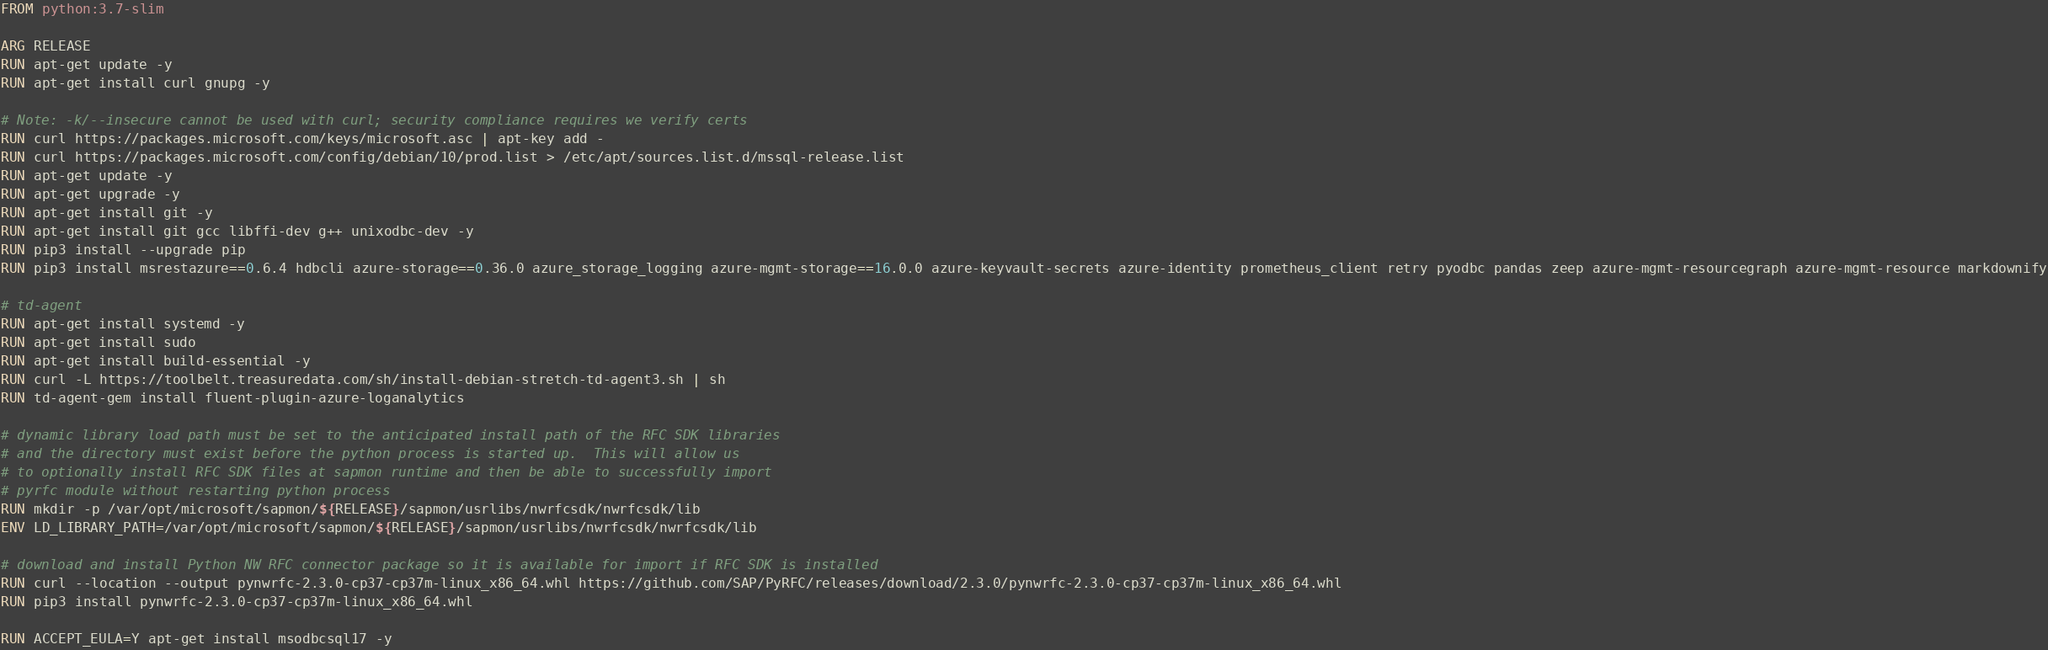<code> <loc_0><loc_0><loc_500><loc_500><_Dockerfile_>FROM python:3.7-slim

ARG RELEASE
RUN apt-get update -y
RUN apt-get install curl gnupg -y

# Note: -k/--insecure cannot be used with curl; security compliance requires we verify certs
RUN curl https://packages.microsoft.com/keys/microsoft.asc | apt-key add -
RUN curl https://packages.microsoft.com/config/debian/10/prod.list > /etc/apt/sources.list.d/mssql-release.list
RUN apt-get update -y
RUN apt-get upgrade -y
RUN apt-get install git -y
RUN apt-get install git gcc libffi-dev g++ unixodbc-dev -y
RUN pip3 install --upgrade pip
RUN pip3 install msrestazure==0.6.4 hdbcli azure-storage==0.36.0 azure_storage_logging azure-mgmt-storage==16.0.0 azure-keyvault-secrets azure-identity prometheus_client retry pyodbc pandas zeep azure-mgmt-resourcegraph azure-mgmt-resource markdownify

# td-agent
RUN apt-get install systemd -y
RUN apt-get install sudo
RUN apt-get install build-essential -y
RUN curl -L https://toolbelt.treasuredata.com/sh/install-debian-stretch-td-agent3.sh | sh
RUN td-agent-gem install fluent-plugin-azure-loganalytics

# dynamic library load path must be set to the anticipated install path of the RFC SDK libraries
# and the directory must exist before the python process is started up.  This will allow us
# to optionally install RFC SDK files at sapmon runtime and then be able to successfully import
# pyrfc module without restarting python process
RUN mkdir -p /var/opt/microsoft/sapmon/${RELEASE}/sapmon/usrlibs/nwrfcsdk/nwrfcsdk/lib
ENV LD_LIBRARY_PATH=/var/opt/microsoft/sapmon/${RELEASE}/sapmon/usrlibs/nwrfcsdk/nwrfcsdk/lib

# download and install Python NW RFC connector package so it is available for import if RFC SDK is installed
RUN curl --location --output pynwrfc-2.3.0-cp37-cp37m-linux_x86_64.whl https://github.com/SAP/PyRFC/releases/download/2.3.0/pynwrfc-2.3.0-cp37-cp37m-linux_x86_64.whl
RUN pip3 install pynwrfc-2.3.0-cp37-cp37m-linux_x86_64.whl

RUN ACCEPT_EULA=Y apt-get install msodbcsql17 -y</code> 